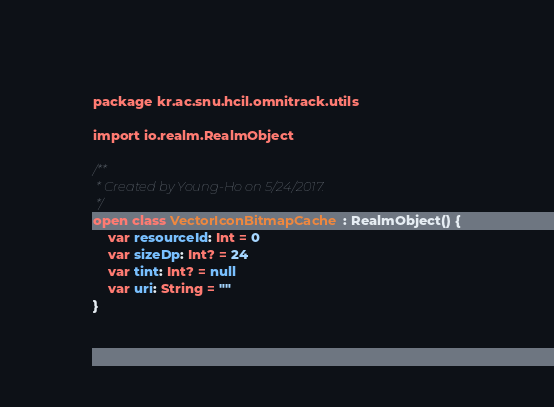<code> <loc_0><loc_0><loc_500><loc_500><_Kotlin_>package kr.ac.snu.hcil.omnitrack.utils

import io.realm.RealmObject

/**
 * Created by Young-Ho on 5/24/2017.
 */
open class VectorIconBitmapCache : RealmObject() {
    var resourceId: Int = 0
    var sizeDp: Int? = 24
    var tint: Int? = null
    var uri: String = ""
}</code> 